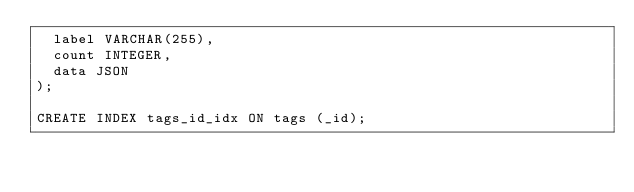Convert code to text. <code><loc_0><loc_0><loc_500><loc_500><_SQL_>  label VARCHAR(255),
  count INTEGER,
  data JSON
);

CREATE INDEX tags_id_idx ON tags (_id);</code> 